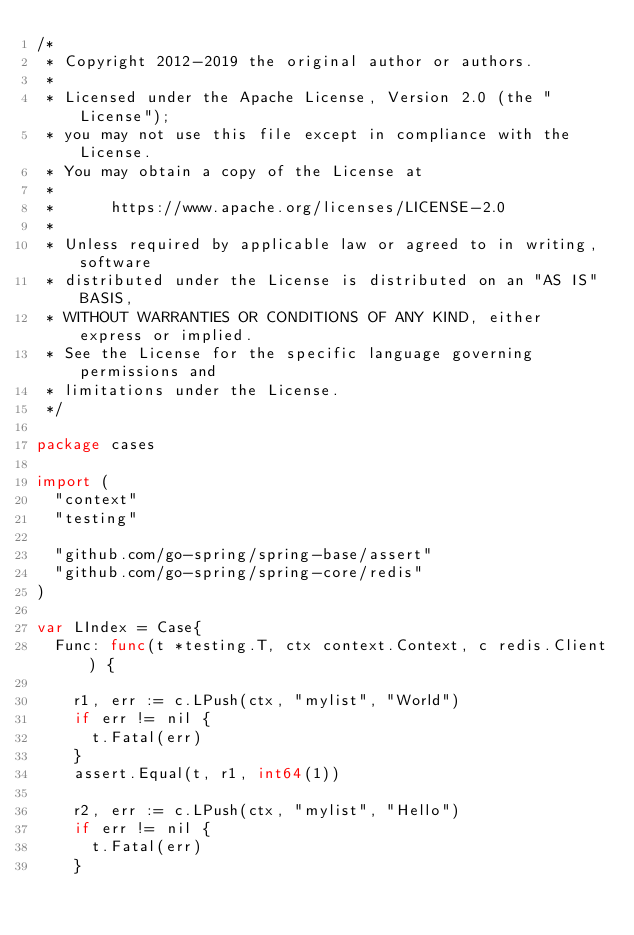Convert code to text. <code><loc_0><loc_0><loc_500><loc_500><_Go_>/*
 * Copyright 2012-2019 the original author or authors.
 *
 * Licensed under the Apache License, Version 2.0 (the "License");
 * you may not use this file except in compliance with the License.
 * You may obtain a copy of the License at
 *
 *      https://www.apache.org/licenses/LICENSE-2.0
 *
 * Unless required by applicable law or agreed to in writing, software
 * distributed under the License is distributed on an "AS IS" BASIS,
 * WITHOUT WARRANTIES OR CONDITIONS OF ANY KIND, either express or implied.
 * See the License for the specific language governing permissions and
 * limitations under the License.
 */

package cases

import (
	"context"
	"testing"

	"github.com/go-spring/spring-base/assert"
	"github.com/go-spring/spring-core/redis"
)

var LIndex = Case{
	Func: func(t *testing.T, ctx context.Context, c redis.Client) {

		r1, err := c.LPush(ctx, "mylist", "World")
		if err != nil {
			t.Fatal(err)
		}
		assert.Equal(t, r1, int64(1))

		r2, err := c.LPush(ctx, "mylist", "Hello")
		if err != nil {
			t.Fatal(err)
		}</code> 